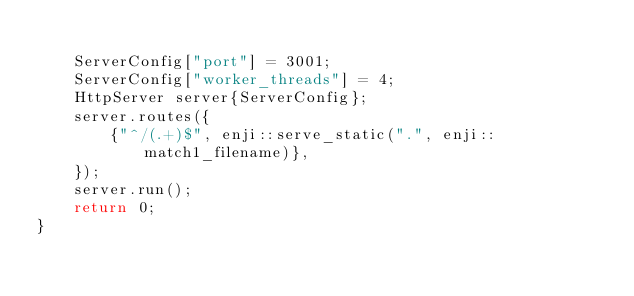<code> <loc_0><loc_0><loc_500><loc_500><_C++_>
    ServerConfig["port"] = 3001;
    ServerConfig["worker_threads"] = 4;
    HttpServer server{ServerConfig};
    server.routes({
        {"^/(.+)$", enji::serve_static(".", enji::match1_filename)},
    });
    server.run();
    return 0;
}</code> 